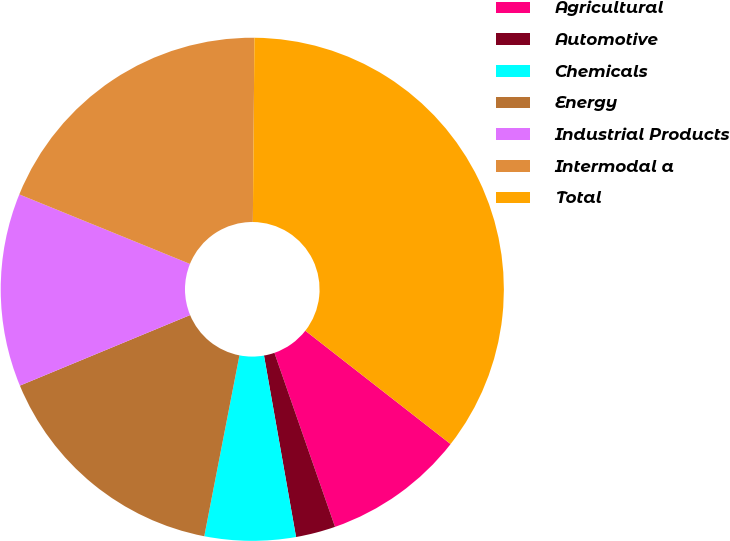<chart> <loc_0><loc_0><loc_500><loc_500><pie_chart><fcel>Agricultural<fcel>Automotive<fcel>Chemicals<fcel>Energy<fcel>Industrial Products<fcel>Intermodal a<fcel>Total<nl><fcel>9.12%<fcel>2.55%<fcel>5.84%<fcel>15.69%<fcel>12.41%<fcel>18.98%<fcel>35.41%<nl></chart> 